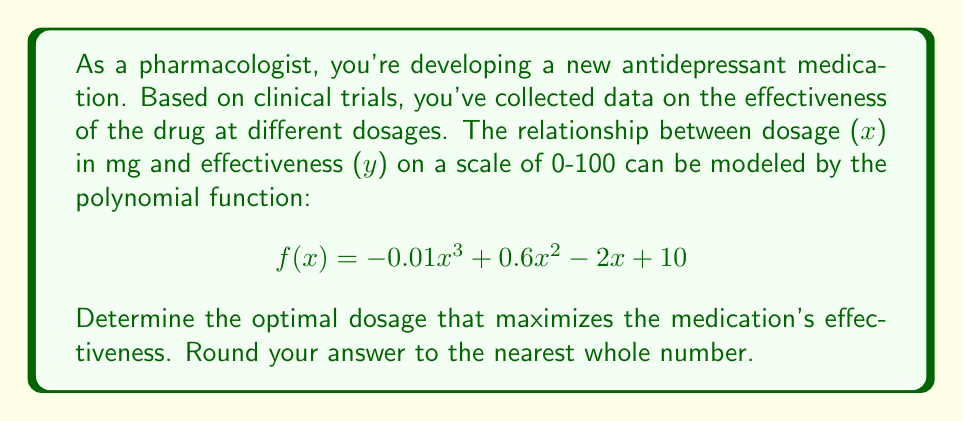Help me with this question. To find the optimal dosage, we need to determine the maximum point of the function. This can be done by following these steps:

1. Find the derivative of the function:
   $$f'(x) = -0.03x^2 + 1.2x - 2$$

2. Set the derivative equal to zero and solve for x:
   $$-0.03x^2 + 1.2x - 2 = 0$$

3. This is a quadratic equation. We can solve it using the quadratic formula:
   $$x = \frac{-b \pm \sqrt{b^2 - 4ac}}{2a}$$
   where $a = -0.03$, $b = 1.2$, and $c = -2$

4. Substituting these values:
   $$x = \frac{-1.2 \pm \sqrt{1.44 - 4(-0.03)(-2)}}{2(-0.03)}$$
   $$x = \frac{-1.2 \pm \sqrt{1.44 - 0.24}}{-0.06}$$
   $$x = \frac{-1.2 \pm \sqrt{1.2}}{-0.06}$$
   $$x = \frac{-1.2 \pm 1.095445}{-0.06}$$

5. This gives us two solutions:
   $$x_1 = \frac{-1.2 + 1.095445}{-0.06} \approx 1.74$$
   $$x_2 = \frac{-1.2 - 1.095445}{-0.06} \approx 38.26$$

6. To determine which of these is the maximum (rather than the minimum), we can check the second derivative:
   $$f''(x) = -0.06x + 1.2$$

7. Evaluating $f''(x)$ at both points:
   $f''(1.74) \approx 1.10 > 0$ (local minimum)
   $f''(38.26) \approx -1.10 < 0$ (local maximum)

8. Therefore, the maximum occurs at $x \approx 38.26$

9. Rounding to the nearest whole number: 38 mg
Answer: 38 mg 